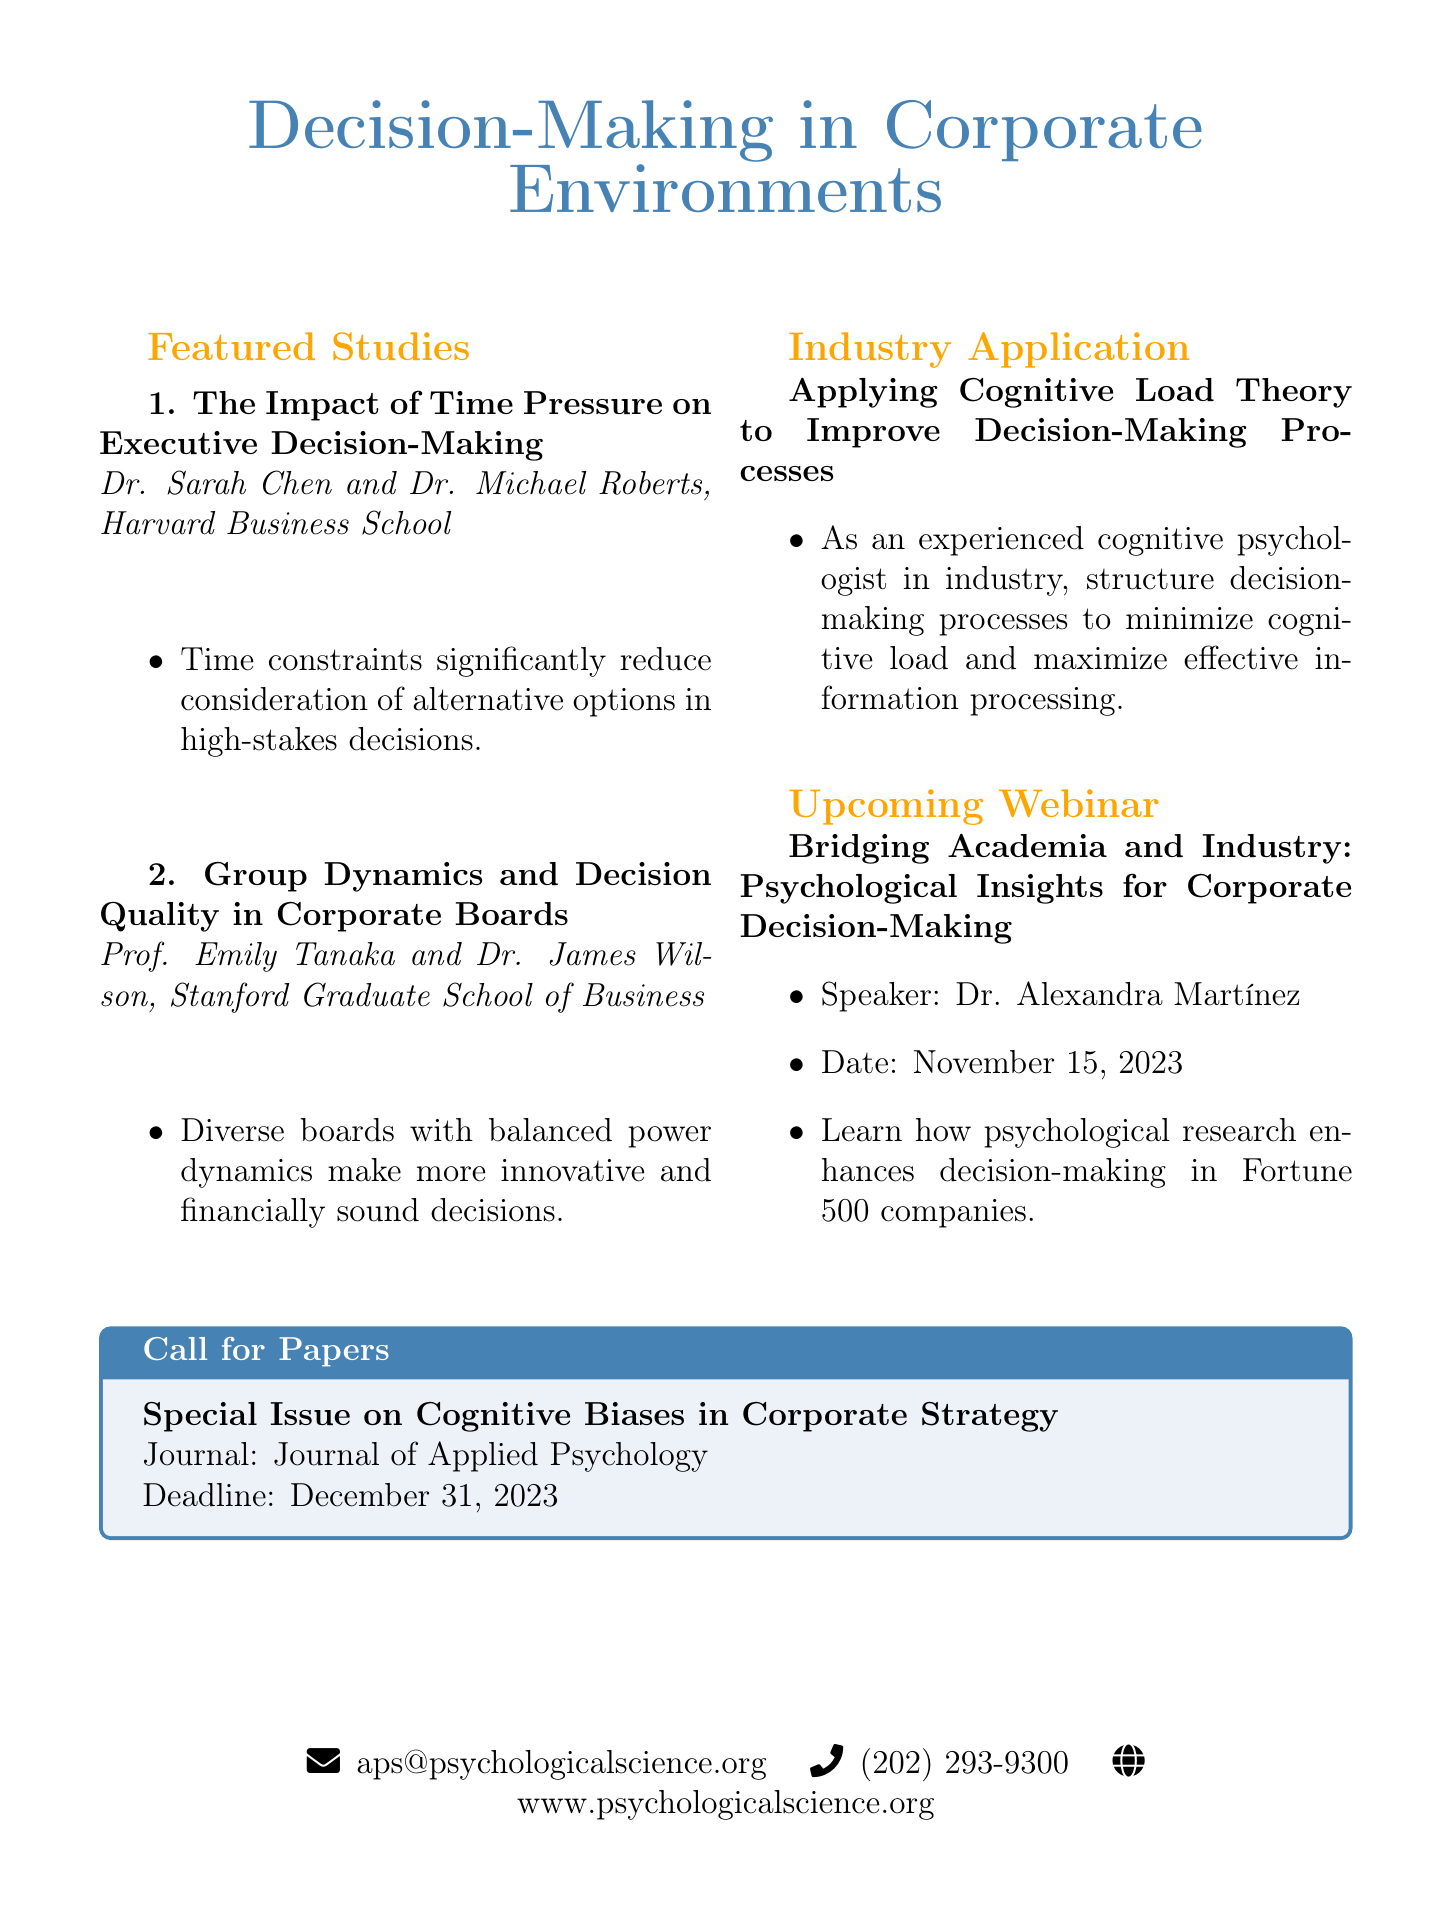What is the title of the newsletter? The title of the newsletter is prominently displayed at the top of the document.
Answer: APS Insights: Decision-Making in Corporate Environments Who are the authors of the first featured study? The authors of the featured study are listed directly under the study title.
Answer: Dr. Sarah Chen and Dr. Michael Roberts What date is the upcoming webinar scheduled for? The date for the upcoming webinar is mentioned in the description section of the document.
Answer: November 15, 2023 What is the key finding of the second featured study? The key finding of the second featured study is included in the bullet points under the study.
Answer: Diverse boards with balanced power dynamics make more innovative and financially sound decisions What is the deadline for the call for papers? The deadline is stated in the special issue section of the document.
Answer: December 31, 2023 